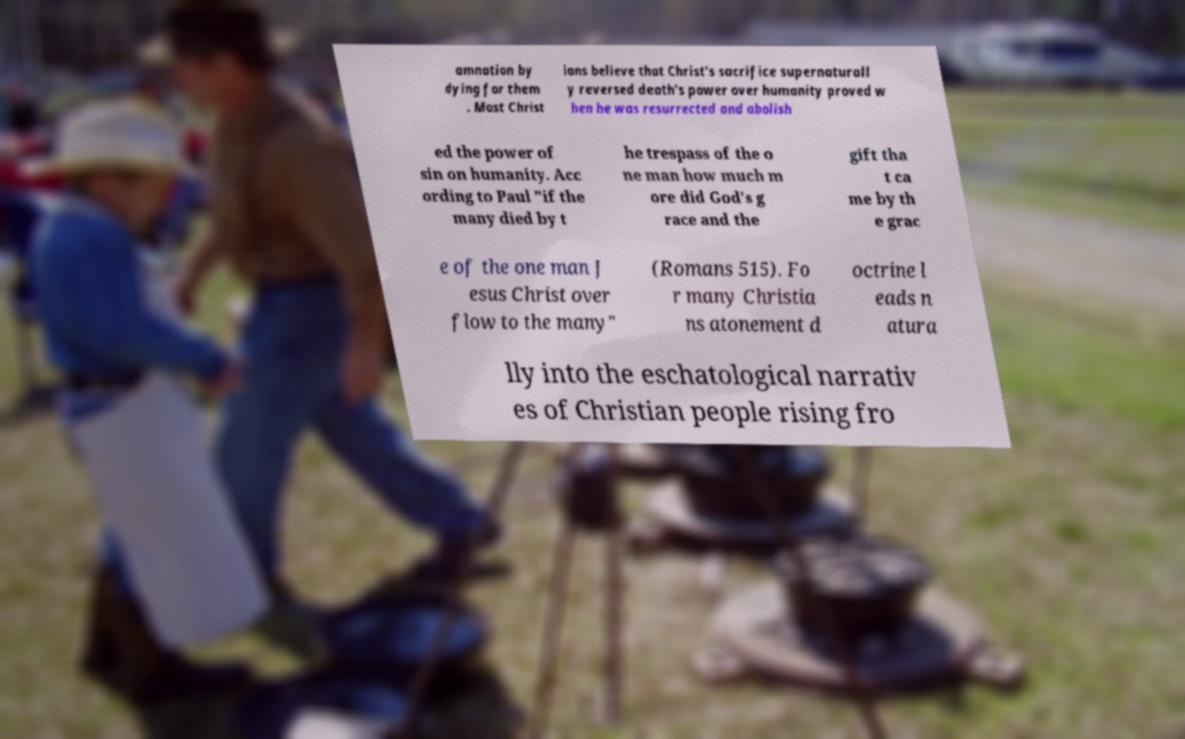Could you extract and type out the text from this image? amnation by dying for them . Most Christ ians believe that Christ's sacrifice supernaturall y reversed death's power over humanity proved w hen he was resurrected and abolish ed the power of sin on humanity. Acc ording to Paul "if the many died by t he trespass of the o ne man how much m ore did God's g race and the gift tha t ca me by th e grac e of the one man J esus Christ over flow to the many" (Romans 515). Fo r many Christia ns atonement d octrine l eads n atura lly into the eschatological narrativ es of Christian people rising fro 